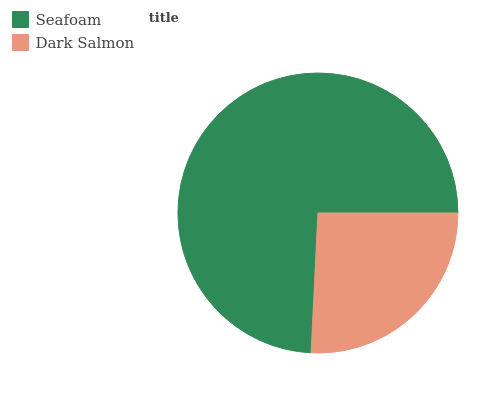Is Dark Salmon the minimum?
Answer yes or no. Yes. Is Seafoam the maximum?
Answer yes or no. Yes. Is Dark Salmon the maximum?
Answer yes or no. No. Is Seafoam greater than Dark Salmon?
Answer yes or no. Yes. Is Dark Salmon less than Seafoam?
Answer yes or no. Yes. Is Dark Salmon greater than Seafoam?
Answer yes or no. No. Is Seafoam less than Dark Salmon?
Answer yes or no. No. Is Seafoam the high median?
Answer yes or no. Yes. Is Dark Salmon the low median?
Answer yes or no. Yes. Is Dark Salmon the high median?
Answer yes or no. No. Is Seafoam the low median?
Answer yes or no. No. 